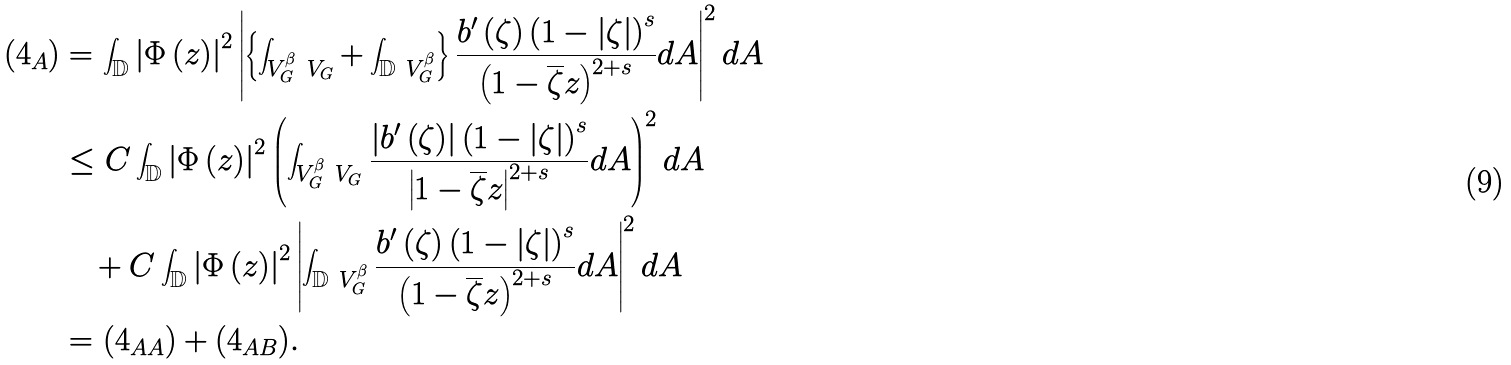Convert formula to latex. <formula><loc_0><loc_0><loc_500><loc_500>( 4 _ { A } ) & = \int _ { \mathbb { D } } \left | \Phi \left ( z \right ) \right | ^ { 2 } \left | \left \{ \int _ { V _ { G } ^ { \beta } \ V _ { G } } + \int _ { \mathbb { D } \ V _ { G } ^ { \beta } } \right \} \frac { b ^ { \prime } \left ( \zeta \right ) \left ( 1 - \left | \zeta \right | \right ) ^ { s } } { \left ( 1 - \overline { \zeta } z \right ) ^ { 2 + s } } d A \right | ^ { 2 } d A \\ & \leq C \int _ { \mathbb { D } } \left | \Phi \left ( z \right ) \right | ^ { 2 } \left ( \int _ { V _ { G } ^ { \beta } \ V _ { G } } \frac { \left | b ^ { \prime } \left ( \zeta \right ) \right | \left ( 1 - \left | \zeta \right | \right ) ^ { s } } { \left | 1 - \overline { \zeta } z \right | ^ { 2 + s } } d A \right ) ^ { 2 } d A \\ & \quad + C \int _ { \mathbb { D } } \left | \Phi \left ( z \right ) \right | ^ { 2 } \left | \int _ { \mathbb { D } \ V _ { G } ^ { \beta } } \frac { b ^ { \prime } \left ( \zeta \right ) \left ( 1 - \left | \zeta \right | \right ) ^ { s } } { \left ( 1 - \overline { \zeta } z \right ) ^ { 2 + s } } d A \right | ^ { 2 } d A \\ & = ( 4 _ { A A } ) + ( 4 _ { A B } ) .</formula> 